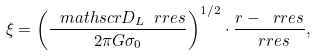<formula> <loc_0><loc_0><loc_500><loc_500>\xi = \left ( \frac { \ m a t h s c r { D } _ { L } \ r r e s } { 2 \pi G \sigma _ { 0 } } \right ) ^ { 1 / 2 } \cdot \frac { r - \ r r e s } { \ r r e s } ,</formula> 